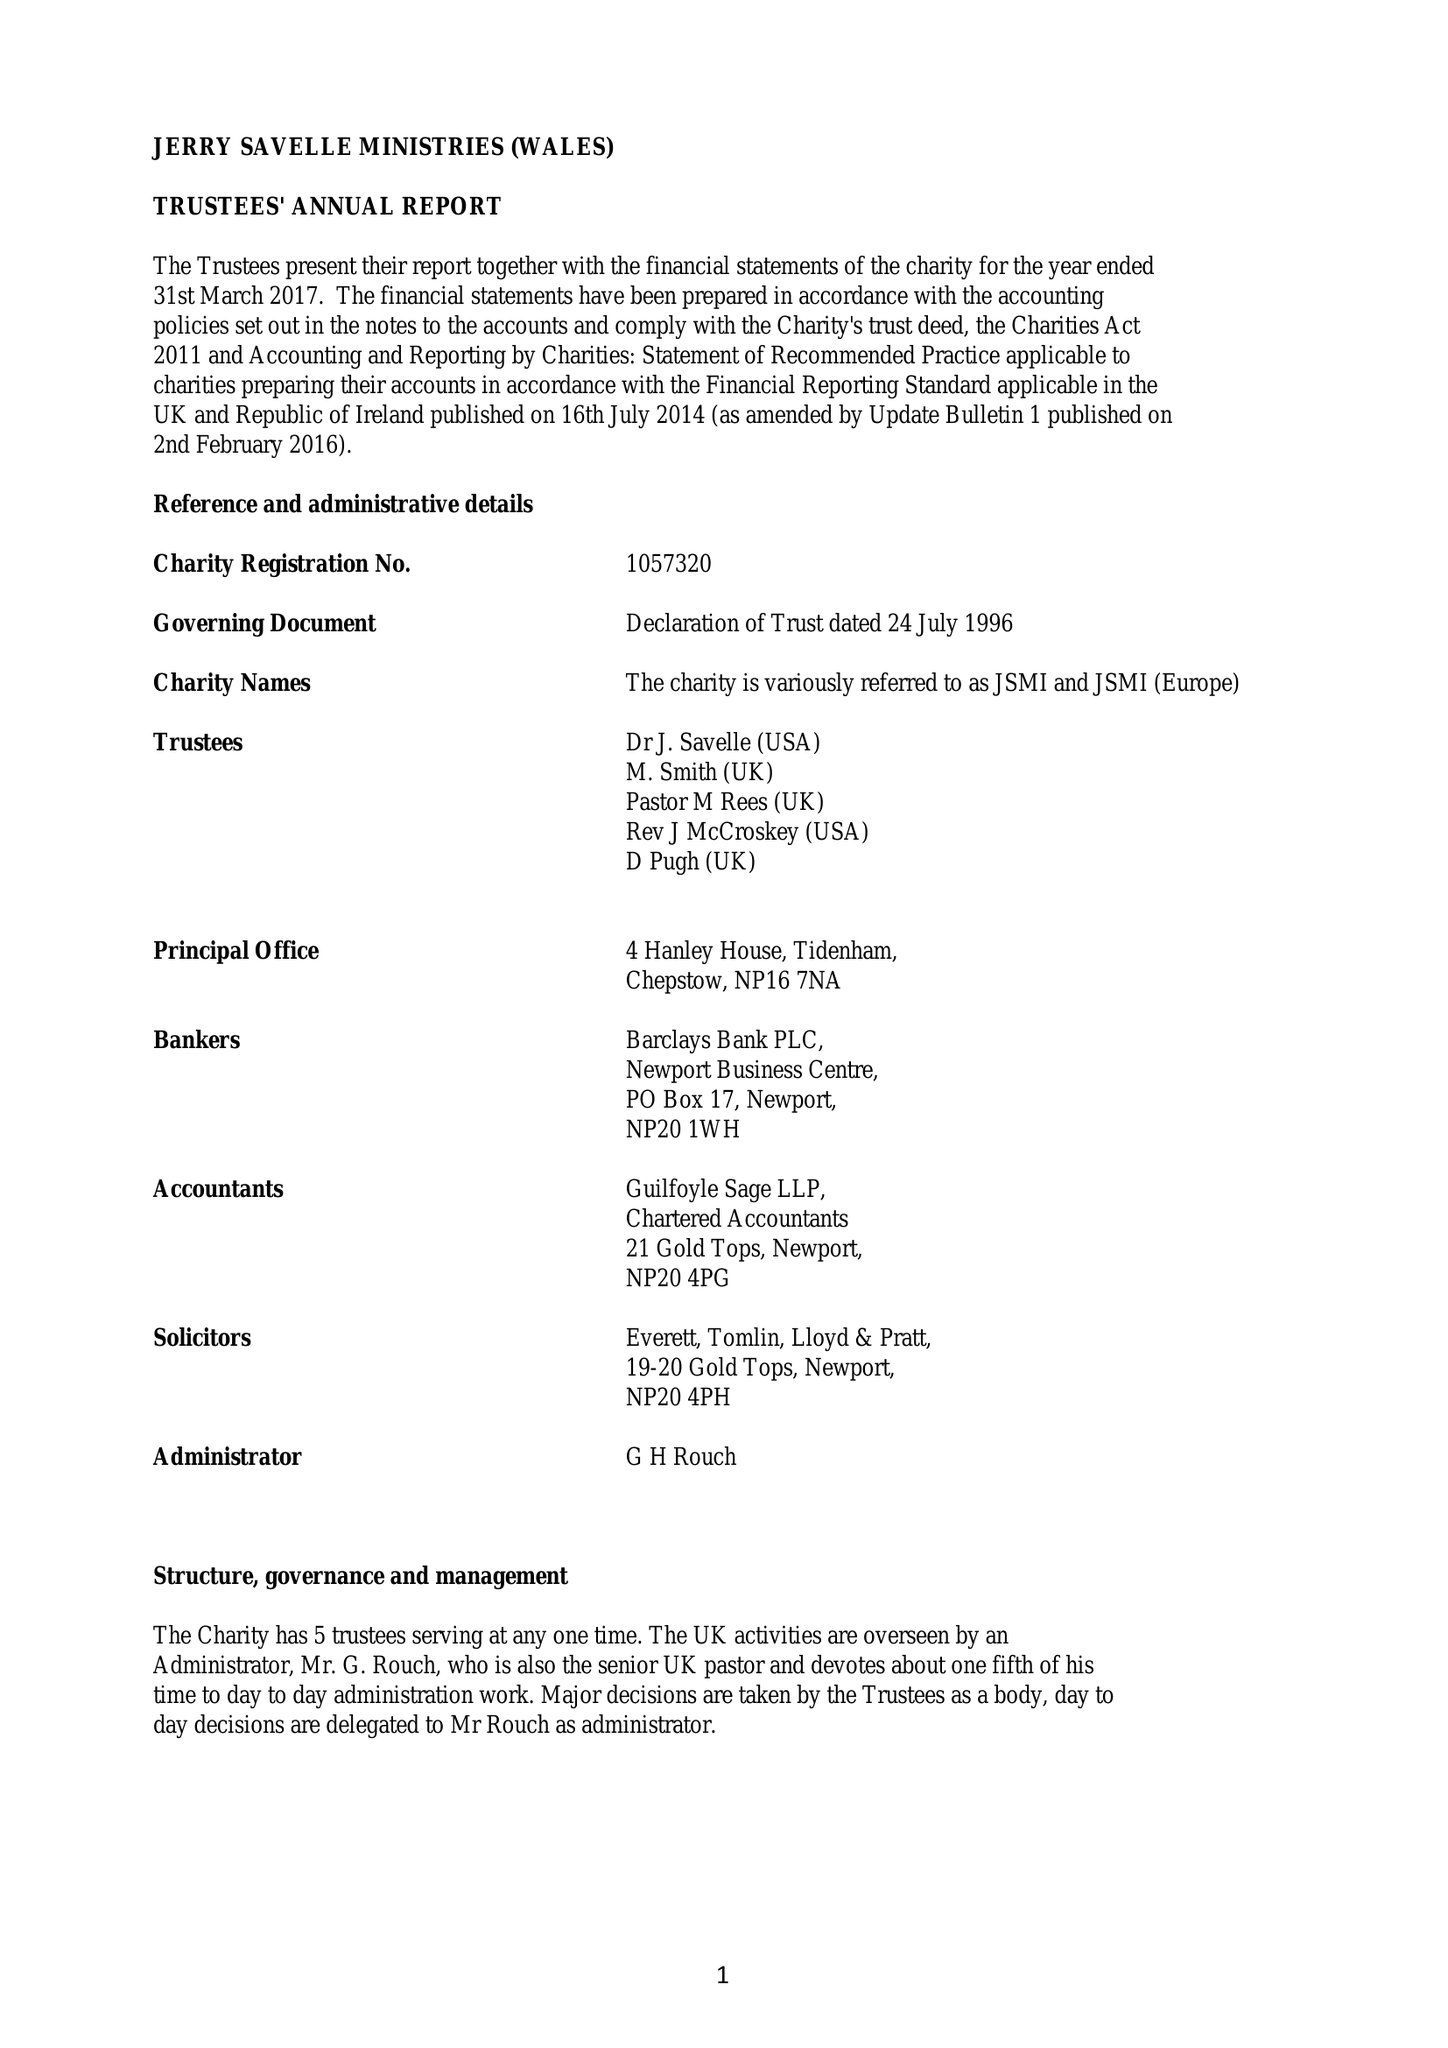What is the value for the charity_number?
Answer the question using a single word or phrase. 1057320 